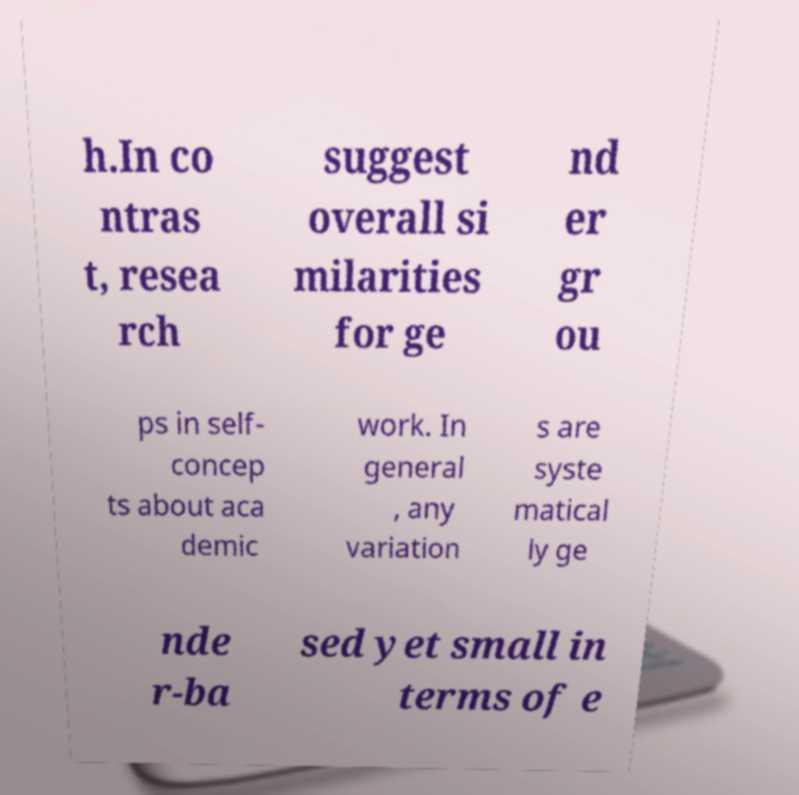Please identify and transcribe the text found in this image. h.In co ntras t, resea rch suggest overall si milarities for ge nd er gr ou ps in self- concep ts about aca demic work. In general , any variation s are syste matical ly ge nde r-ba sed yet small in terms of e 